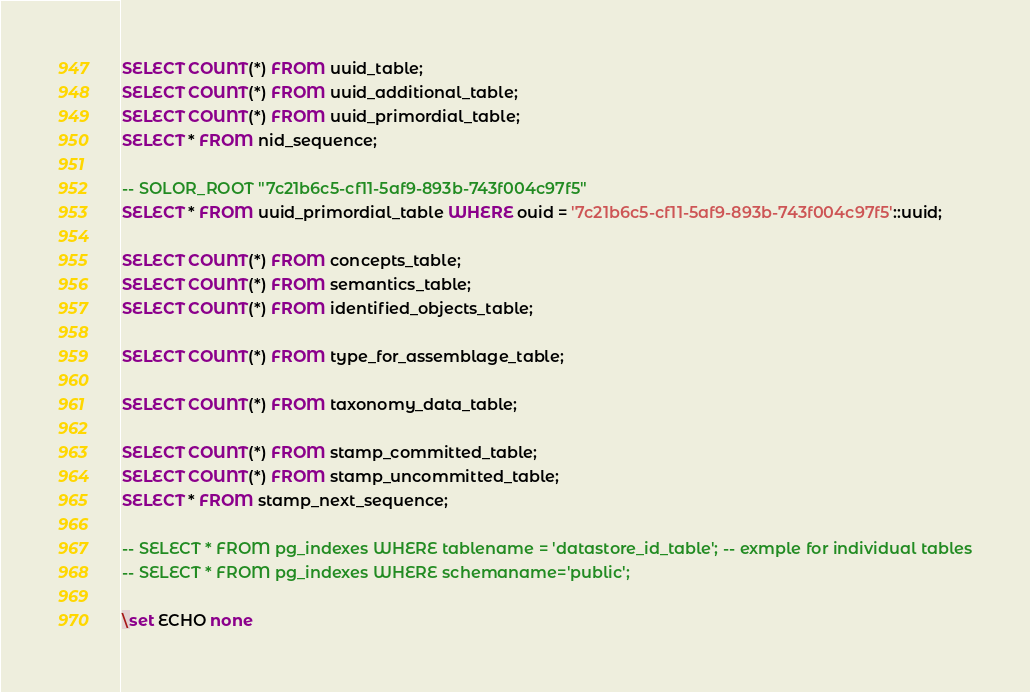Convert code to text. <code><loc_0><loc_0><loc_500><loc_500><_SQL_>SELECT COUNT(*) FROM uuid_table;
SELECT COUNT(*) FROM uuid_additional_table;
SELECT COUNT(*) FROM uuid_primordial_table;
SELECT * FROM nid_sequence;

-- SOLOR_ROOT "7c21b6c5-cf11-5af9-893b-743f004c97f5"
SELECT * FROM uuid_primordial_table WHERE ouid = '7c21b6c5-cf11-5af9-893b-743f004c97f5'::uuid;

SELECT COUNT(*) FROM concepts_table;
SELECT COUNT(*) FROM semantics_table;
SELECT COUNT(*) FROM identified_objects_table;

SELECT COUNT(*) FROM type_for_assemblage_table;

SELECT COUNT(*) FROM taxonomy_data_table;

SELECT COUNT(*) FROM stamp_committed_table;
SELECT COUNT(*) FROM stamp_uncommitted_table;
SELECT * FROM stamp_next_sequence;

-- SELECT * FROM pg_indexes WHERE tablename = 'datastore_id_table'; -- exmple for individual tables
-- SELECT * FROM pg_indexes WHERE schemaname='public';

\set ECHO none
</code> 